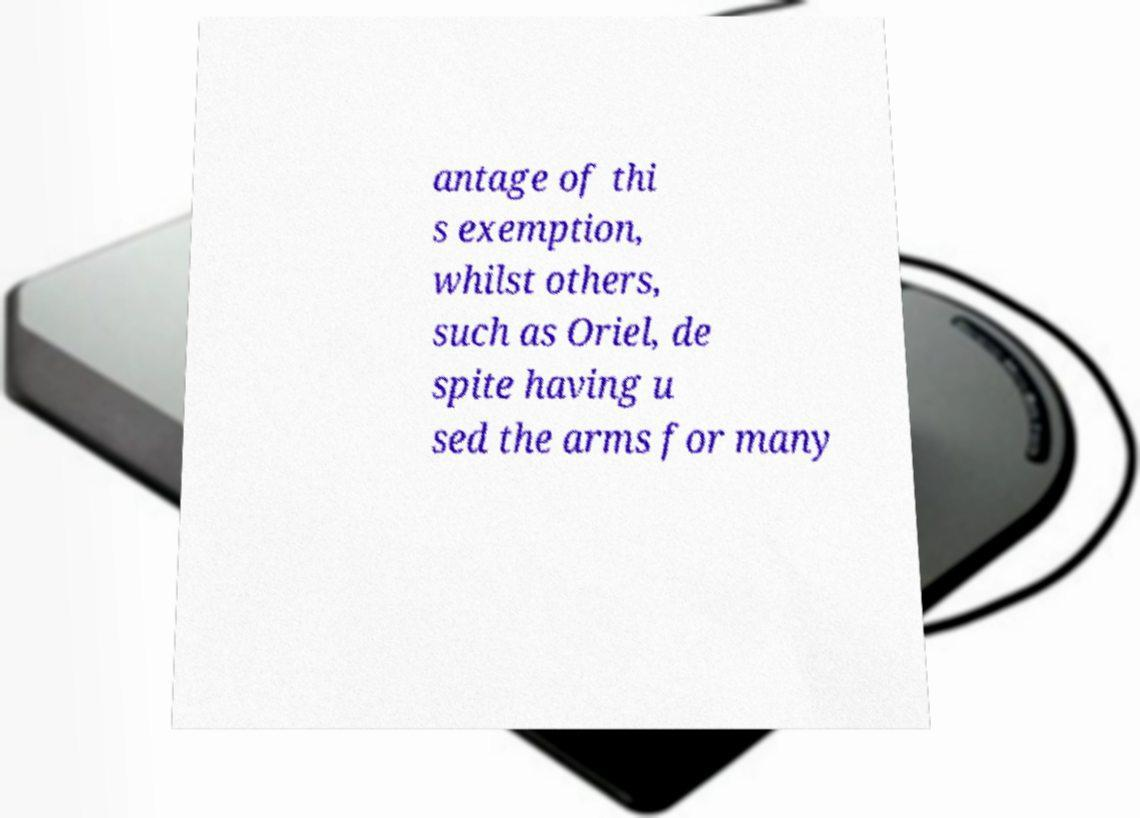Can you read and provide the text displayed in the image?This photo seems to have some interesting text. Can you extract and type it out for me? antage of thi s exemption, whilst others, such as Oriel, de spite having u sed the arms for many 